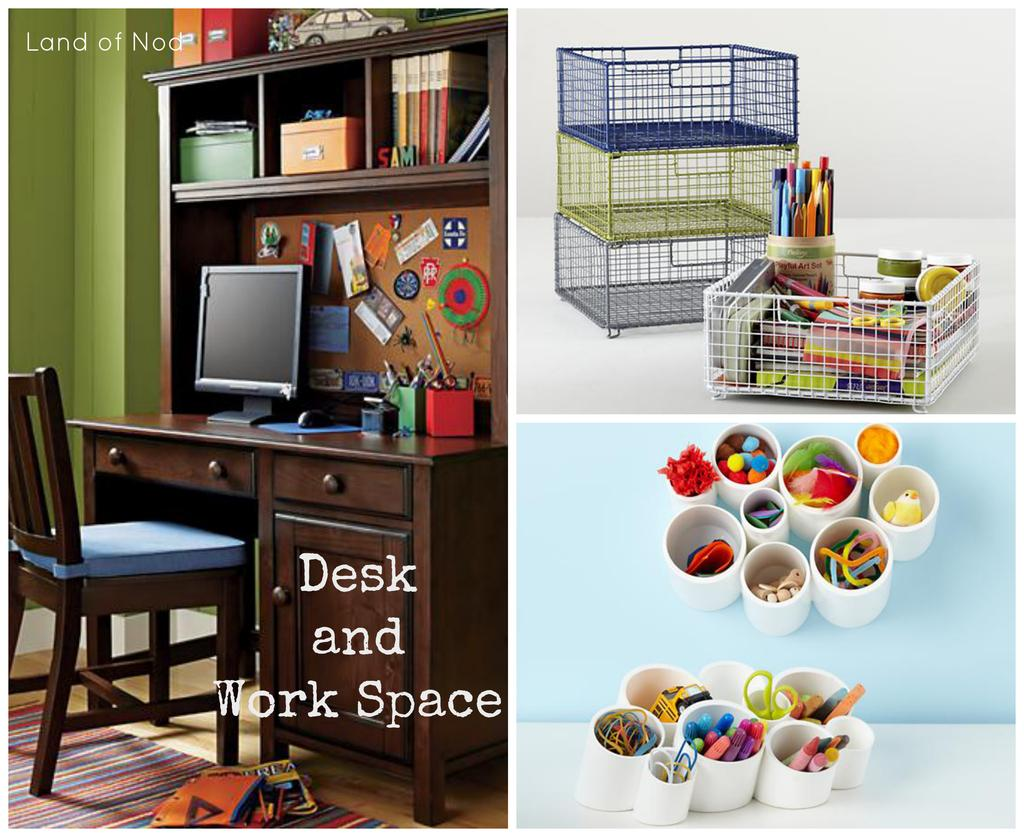<image>
Render a clear and concise summary of the photo. Three pictures of a desk and work space and top of desk supplies. 